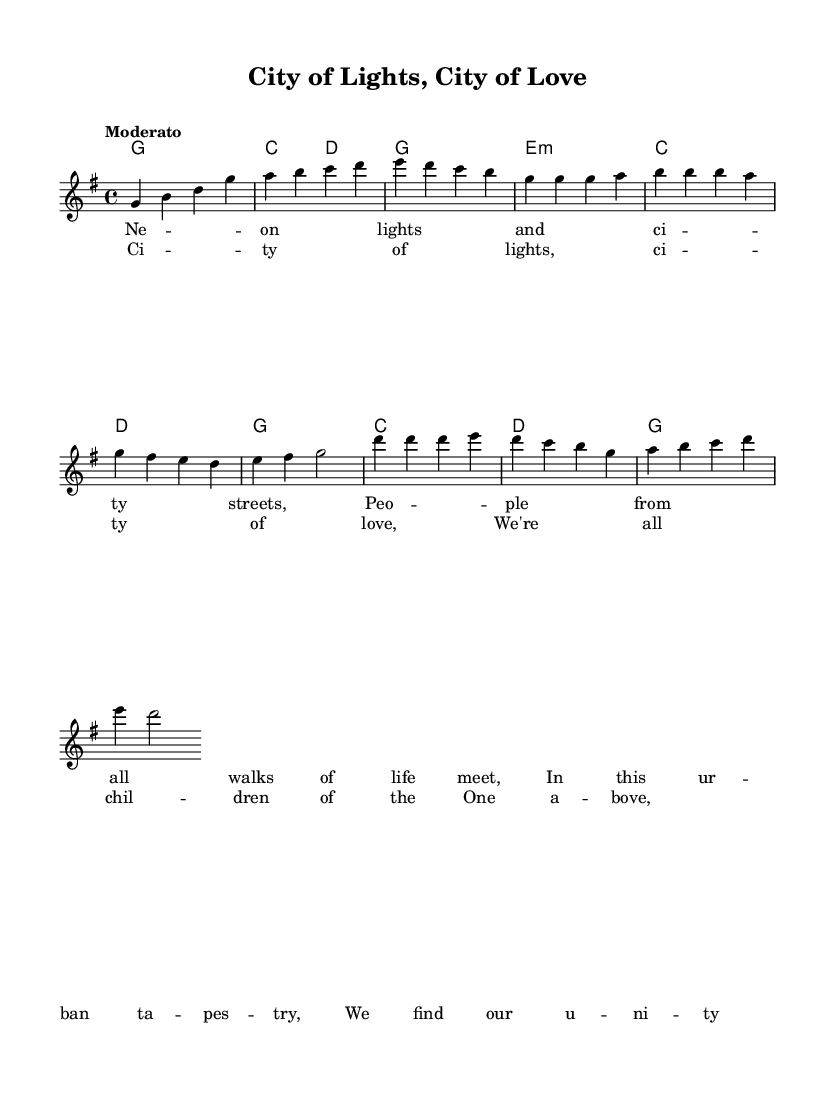What is the key signature of this music? The key signature indicated at the beginning of the piece shows one sharp, which corresponds to the key of G major.
Answer: G major What is the time signature of this music? The time signature, indicated at the beginning, is 4/4, which means there are four beats in each measure.
Answer: 4/4 What tempo marking is indicated for this piece? The tempo marking "Moderato" suggests a moderate speed and is usually understood to indicate a pace of around 108-120 beats per minute.
Answer: Moderato How many measures are in the chorus section? The chorus section has four measures as indicated by the number of groups of notes before each new line of lyrics.
Answer: Four measures What is the first lyric of the verse? The first lyric shown in the verse section is "Neon lights and city streets," which is directly listed beneath the corresponding melody notes.
Answer: Neon lights and city streets How does the melody begin in the introduction? The melody in the introduction starts with the note G and continues with a series of ascending notes G, B, D, G, creating a bright and engaging opening.
Answer: G What do the lyrics of the chorus emphasize about unity? The lyrics of the chorus express a theme of unity by stating "We're all children of the One above," highlighting the idea of a shared connection among diverse people.
Answer: We're all children of the One above 